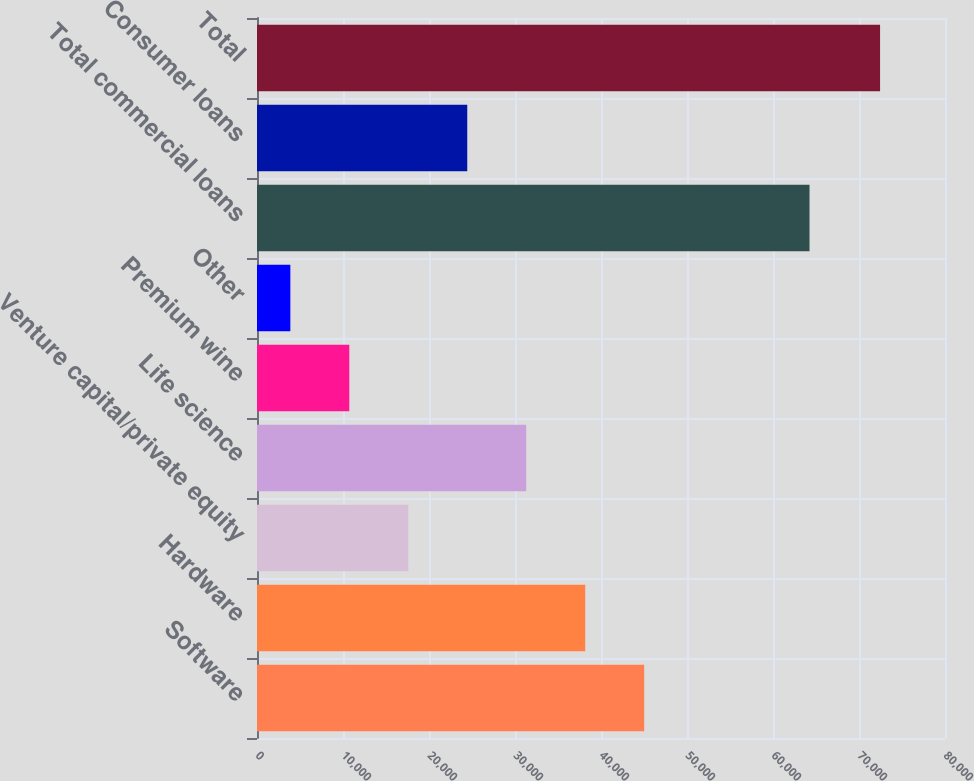Convert chart. <chart><loc_0><loc_0><loc_500><loc_500><bar_chart><fcel>Software<fcel>Hardware<fcel>Venture capital/private equity<fcel>Life science<fcel>Premium wine<fcel>Other<fcel>Total commercial loans<fcel>Consumer loans<fcel>Total<nl><fcel>45020.8<fcel>38163.5<fcel>17591.6<fcel>31306.2<fcel>10734.3<fcel>3877<fcel>64247<fcel>24448.9<fcel>72450<nl></chart> 